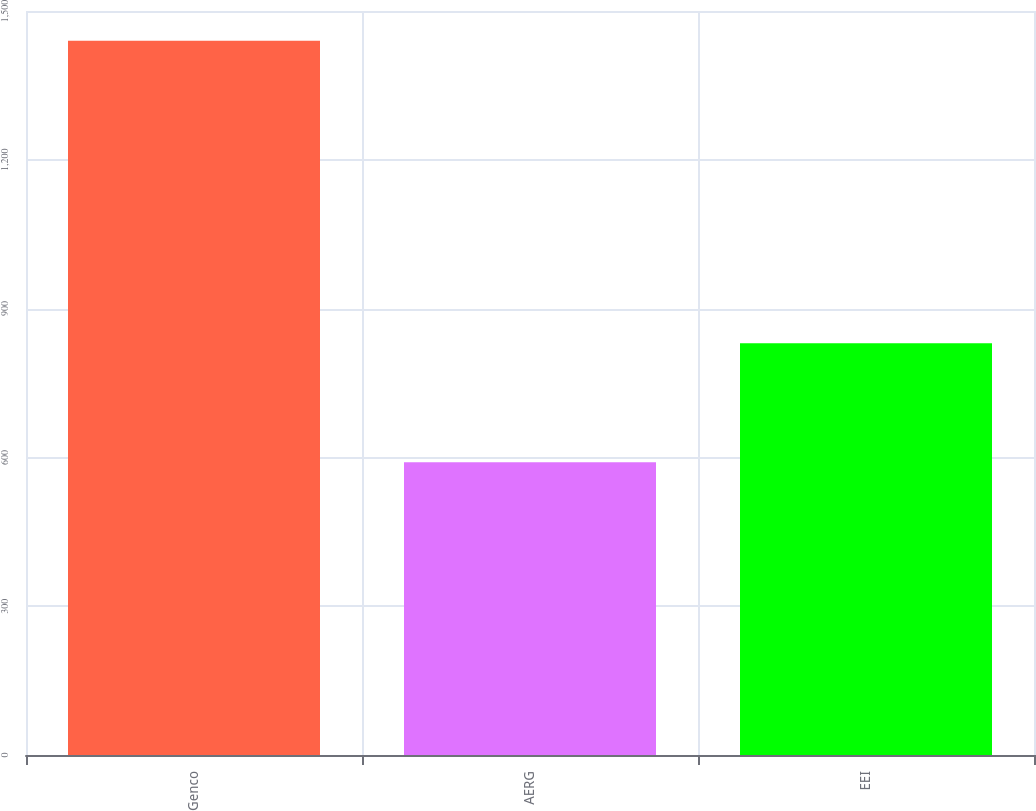<chart> <loc_0><loc_0><loc_500><loc_500><bar_chart><fcel>Genco<fcel>AERG<fcel>EEI<nl><fcel>1440<fcel>590<fcel>830<nl></chart> 